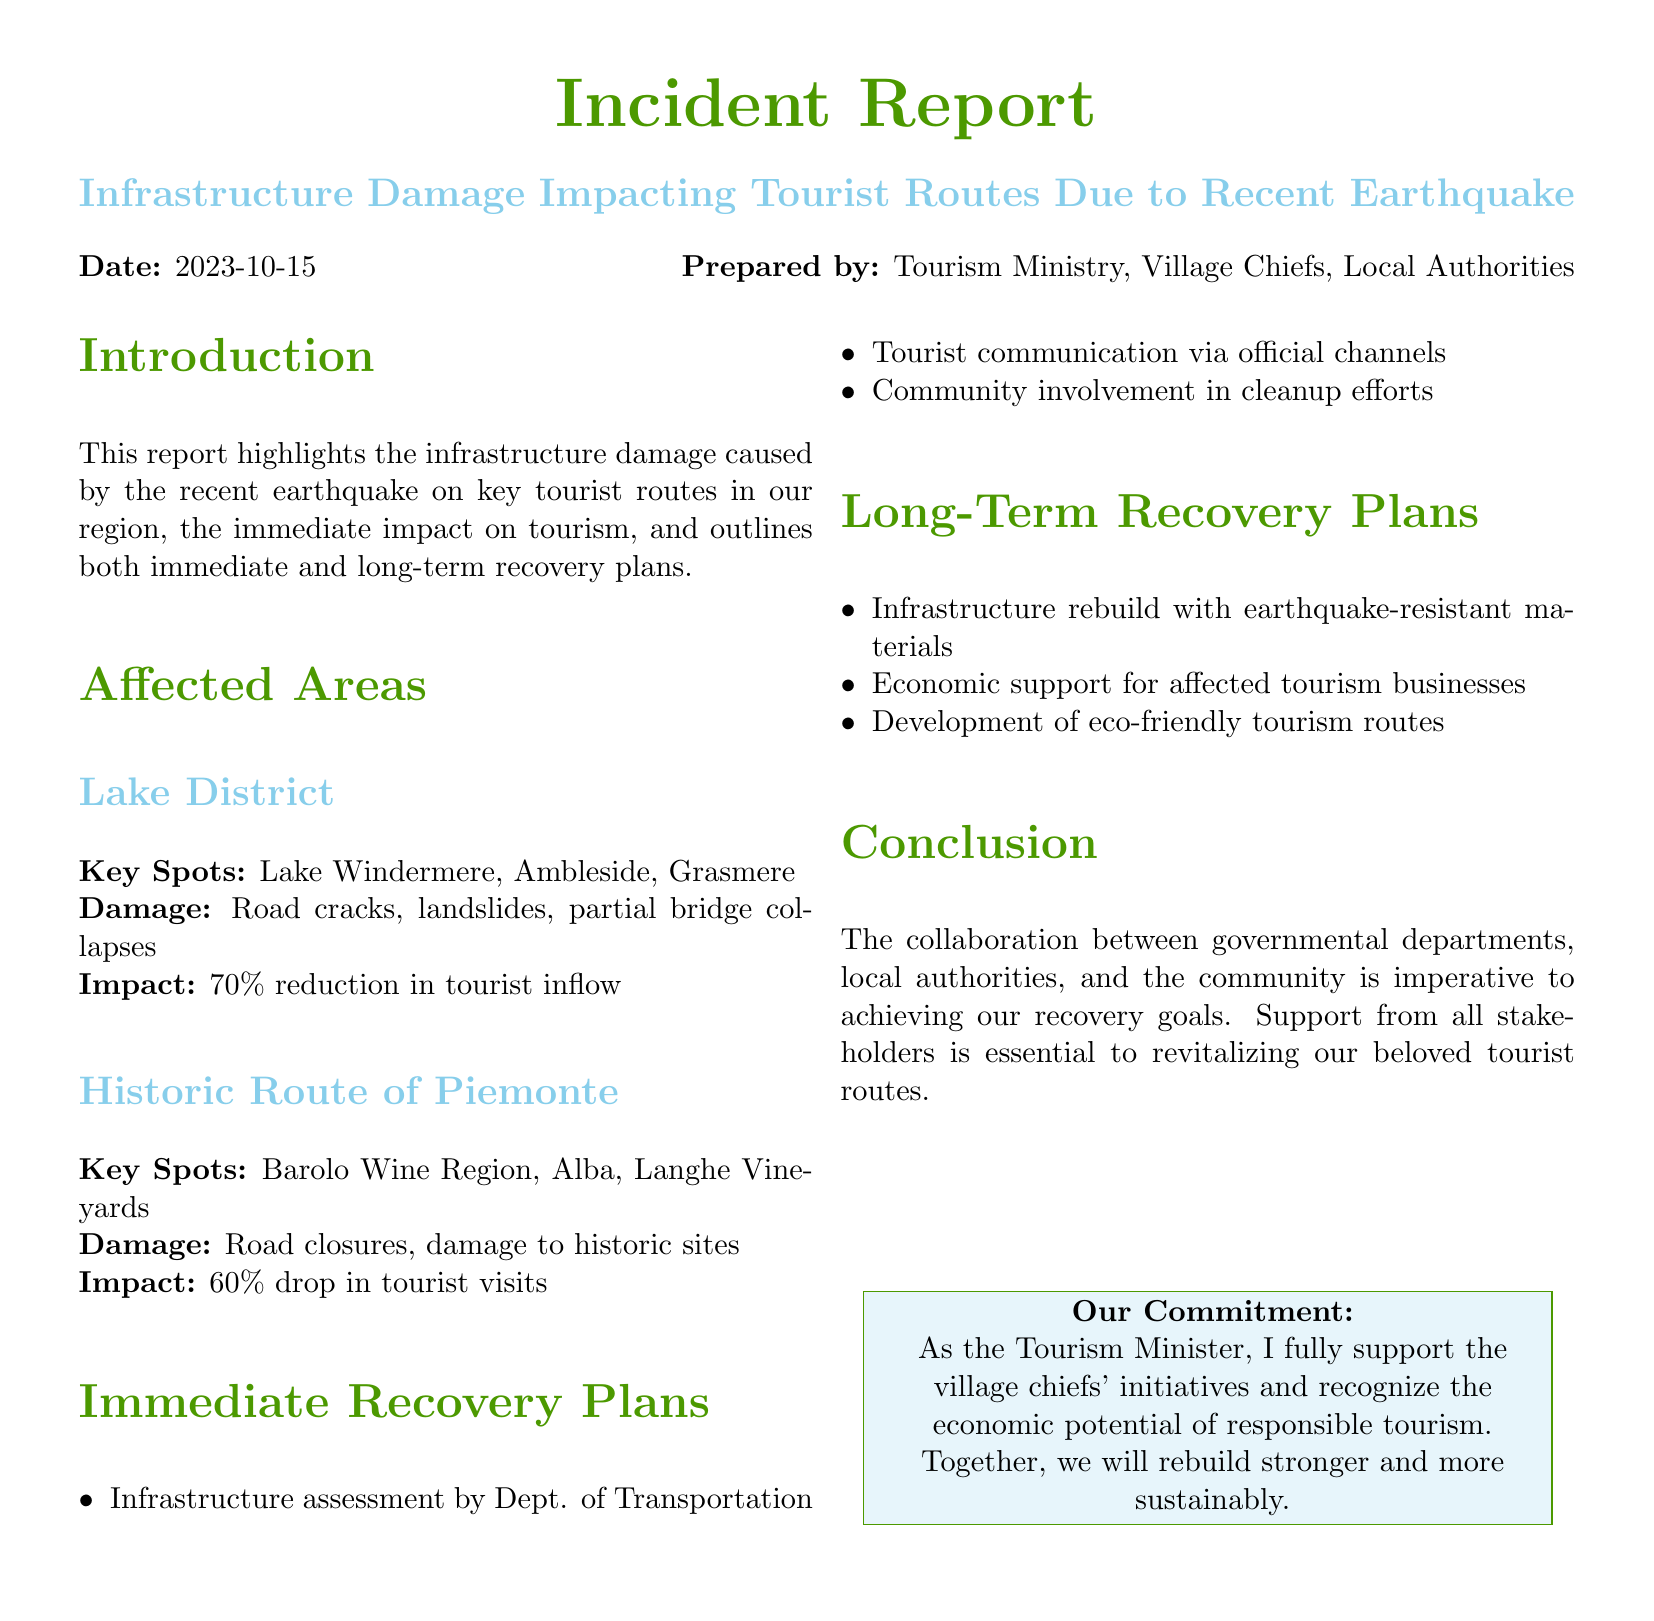What date was the report prepared? The report states the preparation date is included in the header, which is 2023-10-15.
Answer: 2023-10-15 What percentage reduction in tourist inflow was reported for Lake District? The document specifies a 70% reduction in tourist inflow for the Lake District area.
Answer: 70% Which area experienced a 60% drop in tourist visits? The report indicates that the Historic Route of Piemonte had a 60% drop in tourist visits.
Answer: Historic Route of Piemonte What is one immediate recovery plan mentioned? The list of immediate recovery plans includes infrastructure assessment by the Department of Transportation.
Answer: Infrastructure assessment What will the infrastructure be rebuilt with according to long-term plans? The long-term recovery plans emphasize infrastructure rebuild with earthquake-resistant materials.
Answer: Earthquake-resistant materials What is the role of community in the immediate recovery plans? The document mentions community involvement in cleanup efforts as part of the immediate recovery initiatives.
Answer: Cleanup efforts What is the main purpose of this incident report? The introduction outlines that the purpose is to highlight infrastructure damage and outline recovery plans.
Answer: Highlight infrastructure damage What commitment is expressed by the Tourism Minister? The report closes with a commitment to support village chiefs and recognize the potential of responsible tourism.
Answer: Support village chiefs 